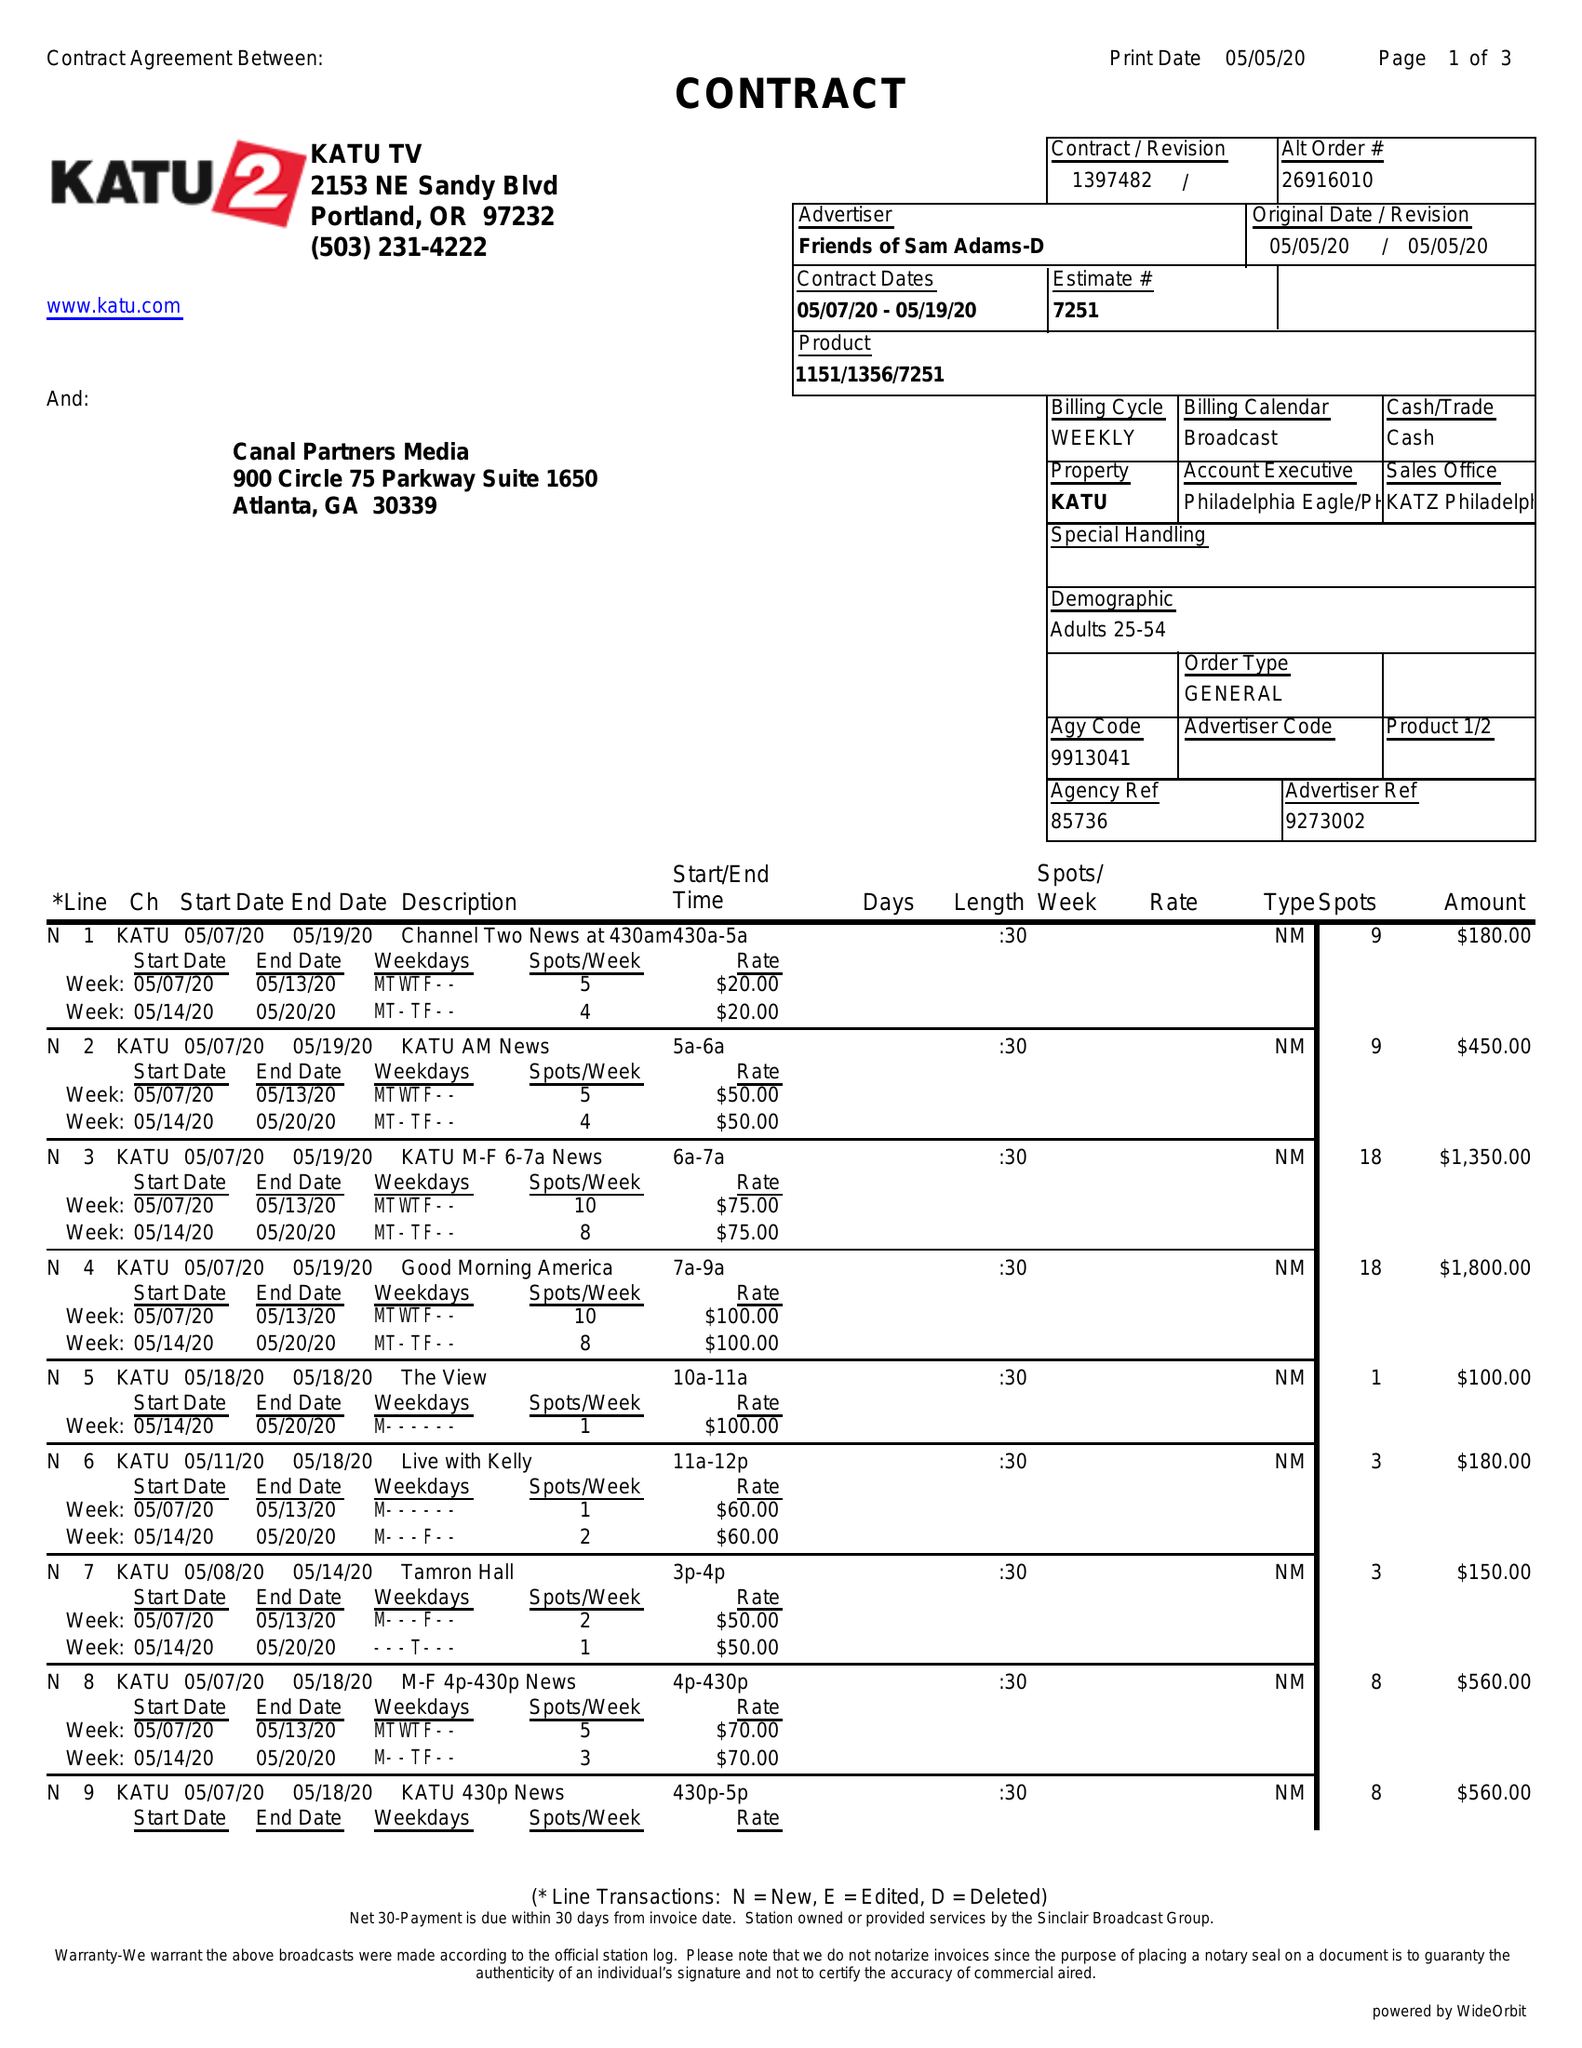What is the value for the flight_from?
Answer the question using a single word or phrase. 05/07/20 